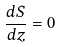<formula> <loc_0><loc_0><loc_500><loc_500>\frac { d S } { d z } = 0</formula> 